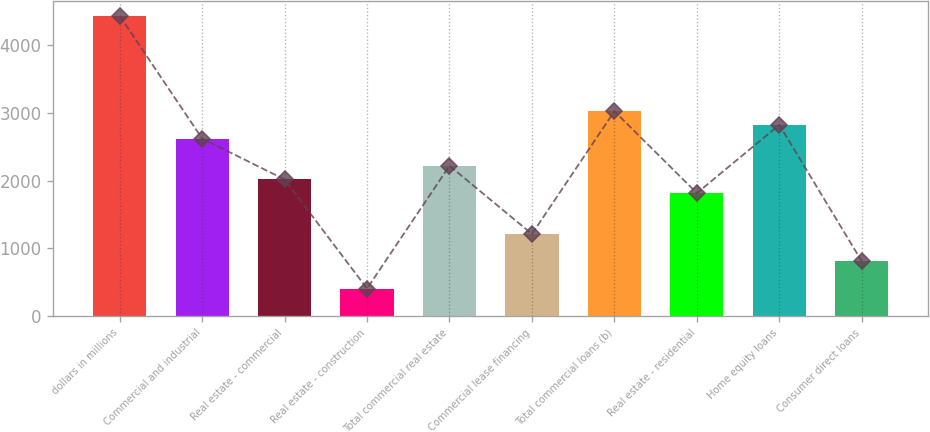Convert chart to OTSL. <chart><loc_0><loc_0><loc_500><loc_500><bar_chart><fcel>dollars in millions<fcel>Commercial and industrial<fcel>Real estate - commercial<fcel>Real estate - construction<fcel>Total commercial real estate<fcel>Commercial lease financing<fcel>Total commercial loans (b)<fcel>Real estate - residential<fcel>Home equity loans<fcel>Consumer direct loans<nl><fcel>4438.89<fcel>2623.23<fcel>2018.01<fcel>404.09<fcel>2219.75<fcel>1211.05<fcel>3026.71<fcel>1816.27<fcel>2824.97<fcel>807.57<nl></chart> 